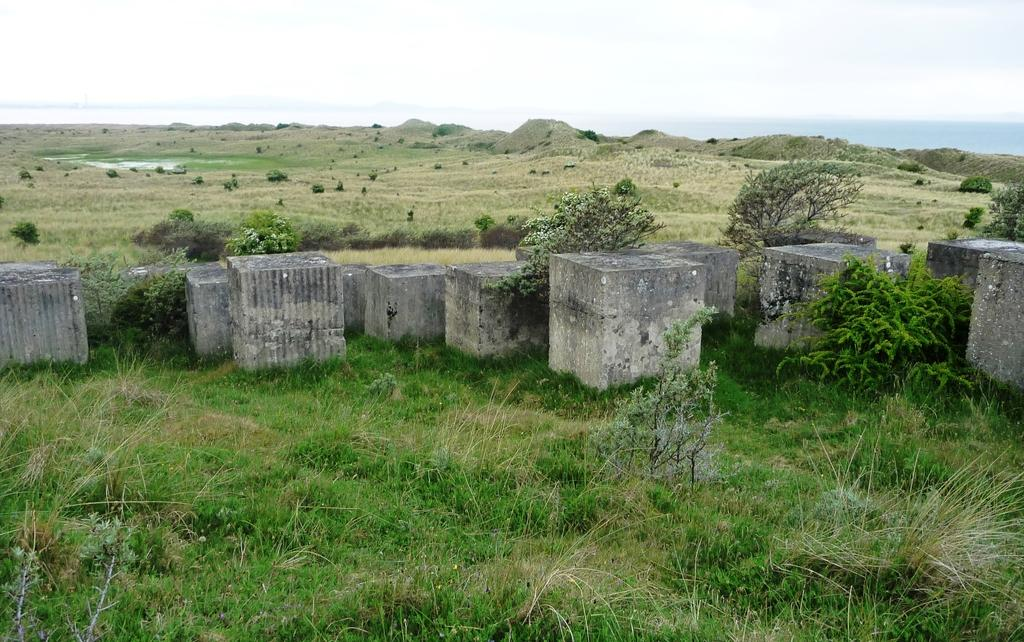What type of vegetation can be seen in the image? There is grass and plants in the image. What architectural features are present in the image? There are pillars in the image. What is the condition of the sky in the image? The sky is clear in the image. What type of stew is being prepared in the image? There is no stew present in the image; it features grass, plants, pillars, and a clear sky. Can you hear a voice speaking in the image? There is no voice or audio present in the image, as it is a static visual representation. 